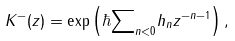Convert formula to latex. <formula><loc_0><loc_0><loc_500><loc_500>K ^ { - } ( z ) = \exp \left ( \hbar { \sum } _ { n < 0 } h _ { n } z ^ { - n - 1 } \right ) ,</formula> 